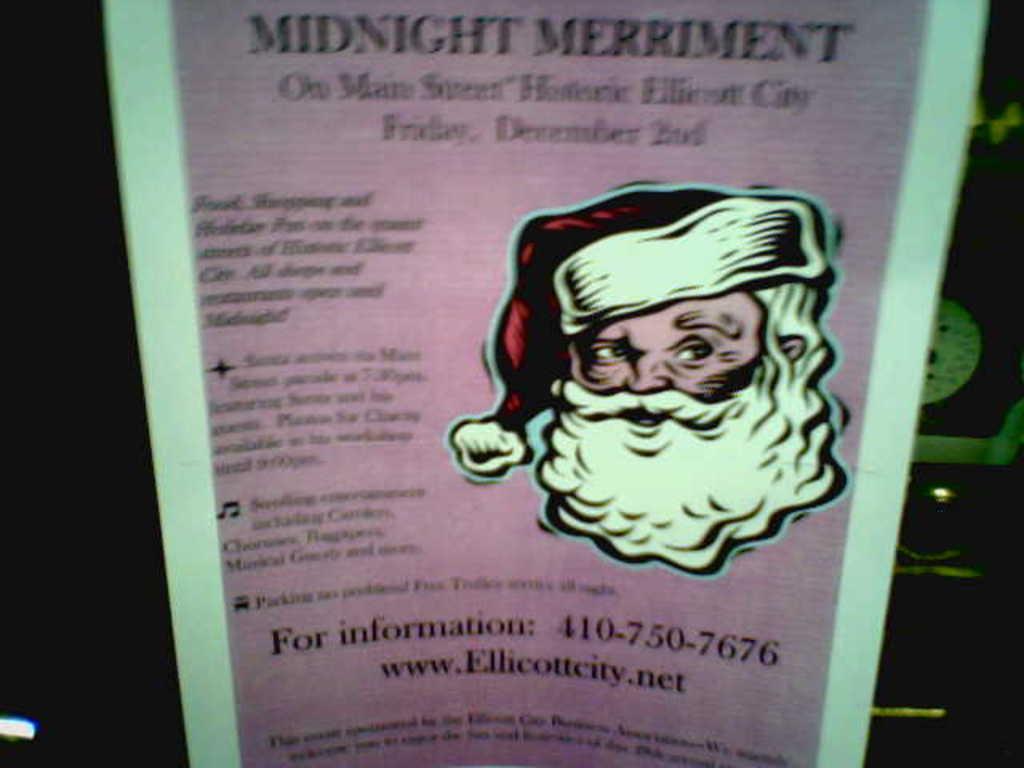Please provide a concise description of this image. In this image there is a poster. There is text on the poster. To the right there is a picture of a Santa Claus on the poster. Behind the poster it is dark. To the right there is an object behind the poster. 